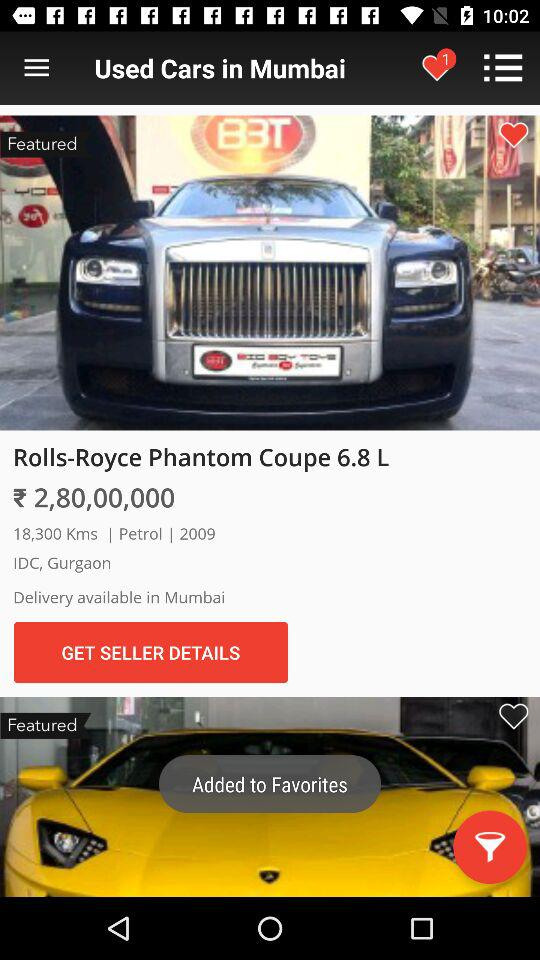What is the fuel type? The fuel type is petrol. 